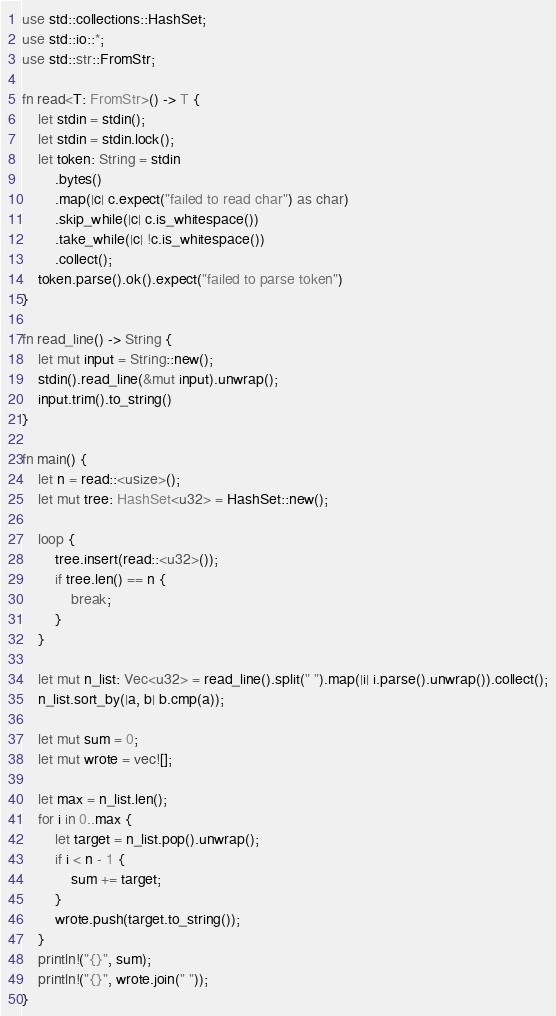Convert code to text. <code><loc_0><loc_0><loc_500><loc_500><_Rust_>use std::collections::HashSet;
use std::io::*;
use std::str::FromStr;

fn read<T: FromStr>() -> T {
    let stdin = stdin();
    let stdin = stdin.lock();
    let token: String = stdin
        .bytes()
        .map(|c| c.expect("failed to read char") as char)
        .skip_while(|c| c.is_whitespace())
        .take_while(|c| !c.is_whitespace())
        .collect();
    token.parse().ok().expect("failed to parse token")
}

fn read_line() -> String {
    let mut input = String::new();
    stdin().read_line(&mut input).unwrap();
    input.trim().to_string()
}

fn main() {
    let n = read::<usize>();
    let mut tree: HashSet<u32> = HashSet::new();

    loop {
        tree.insert(read::<u32>());
        if tree.len() == n {
            break;
        }
    }

    let mut n_list: Vec<u32> = read_line().split(" ").map(|i| i.parse().unwrap()).collect();
    n_list.sort_by(|a, b| b.cmp(a));

    let mut sum = 0;
    let mut wrote = vec![];

    let max = n_list.len();
    for i in 0..max {
        let target = n_list.pop().unwrap();
        if i < n - 1 {
            sum += target;
        }
        wrote.push(target.to_string());
    }
    println!("{}", sum);
    println!("{}", wrote.join(" "));
}
</code> 